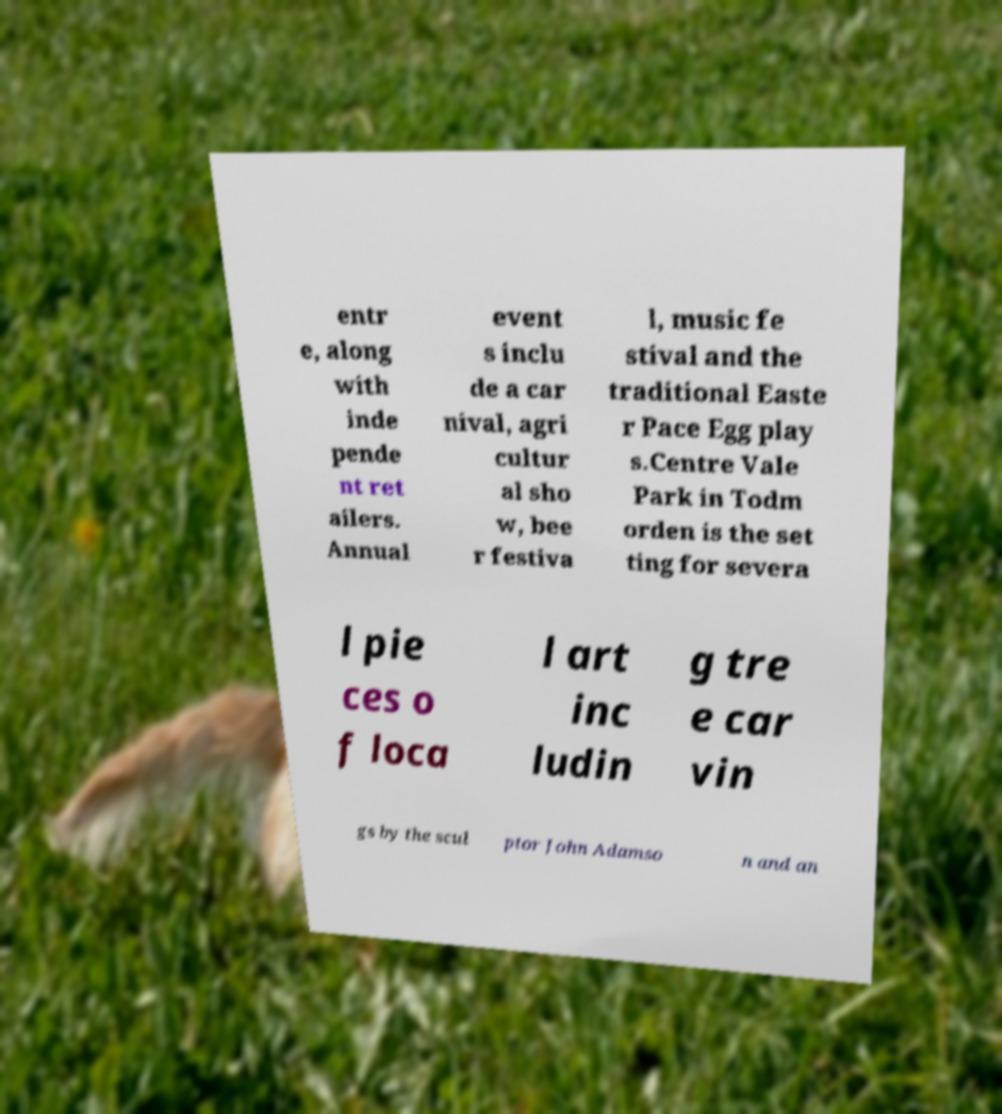What messages or text are displayed in this image? I need them in a readable, typed format. entr e, along with inde pende nt ret ailers. Annual event s inclu de a car nival, agri cultur al sho w, bee r festiva l, music fe stival and the traditional Easte r Pace Egg play s.Centre Vale Park in Todm orden is the set ting for severa l pie ces o f loca l art inc ludin g tre e car vin gs by the scul ptor John Adamso n and an 